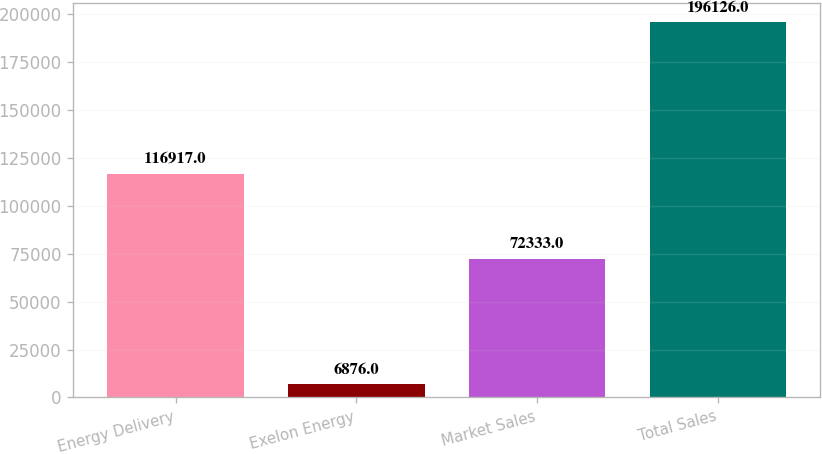Convert chart to OTSL. <chart><loc_0><loc_0><loc_500><loc_500><bar_chart><fcel>Energy Delivery<fcel>Exelon Energy<fcel>Market Sales<fcel>Total Sales<nl><fcel>116917<fcel>6876<fcel>72333<fcel>196126<nl></chart> 